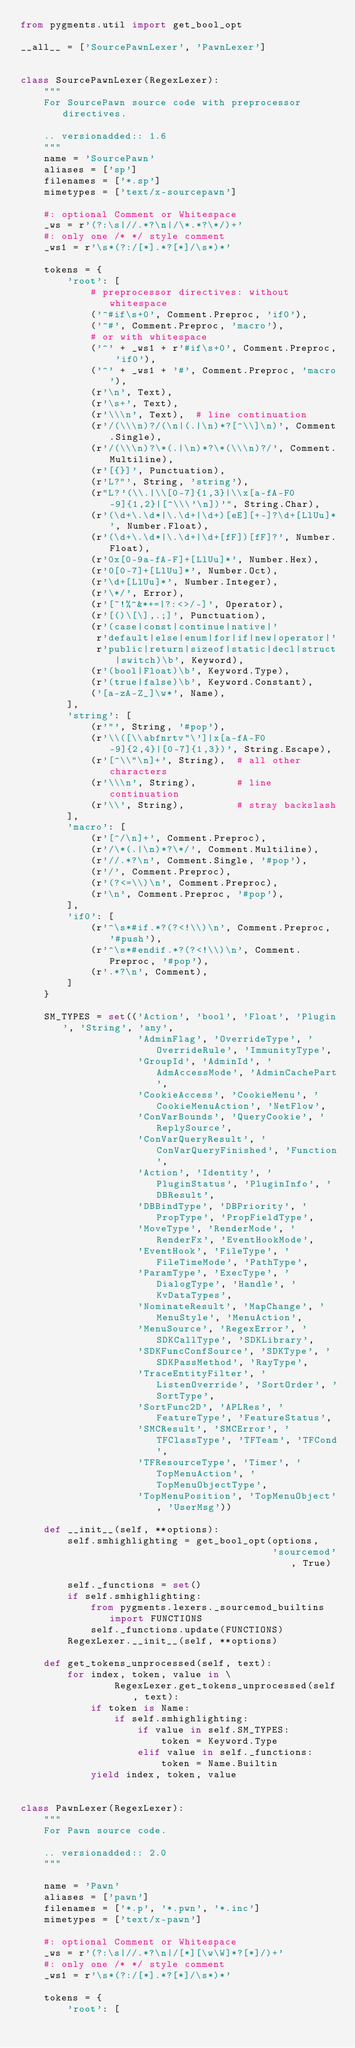Convert code to text. <code><loc_0><loc_0><loc_500><loc_500><_Python_>from pygments.util import get_bool_opt

__all__ = ['SourcePawnLexer', 'PawnLexer']


class SourcePawnLexer(RegexLexer):
    """
    For SourcePawn source code with preprocessor directives.

    .. versionadded:: 1.6
    """
    name = 'SourcePawn'
    aliases = ['sp']
    filenames = ['*.sp']
    mimetypes = ['text/x-sourcepawn']

    #: optional Comment or Whitespace
    _ws = r'(?:\s|//.*?\n|/\*.*?\*/)+'
    #: only one /* */ style comment
    _ws1 = r'\s*(?:/[*].*?[*]/\s*)*'

    tokens = {
        'root': [
            # preprocessor directives: without whitespace
            ('^#if\s+0', Comment.Preproc, 'if0'),
            ('^#', Comment.Preproc, 'macro'),
            # or with whitespace
            ('^' + _ws1 + r'#if\s+0', Comment.Preproc, 'if0'),
            ('^' + _ws1 + '#', Comment.Preproc, 'macro'),
            (r'\n', Text),
            (r'\s+', Text),
            (r'\\\n', Text),  # line continuation
            (r'/(\\\n)?/(\n|(.|\n)*?[^\\]\n)', Comment.Single),
            (r'/(\\\n)?\*(.|\n)*?\*(\\\n)?/', Comment.Multiline),
            (r'[{}]', Punctuation),
            (r'L?"', String, 'string'),
            (r"L?'(\\.|\\[0-7]{1,3}|\\x[a-fA-F0-9]{1,2}|[^\\\'\n])'", String.Char),
            (r'(\d+\.\d*|\.\d+|\d+)[eE][+-]?\d+[LlUu]*', Number.Float),
            (r'(\d+\.\d*|\.\d+|\d+[fF])[fF]?', Number.Float),
            (r'0x[0-9a-fA-F]+[LlUu]*', Number.Hex),
            (r'0[0-7]+[LlUu]*', Number.Oct),
            (r'\d+[LlUu]*', Number.Integer),
            (r'\*/', Error),
            (r'[~!%^&*+=|?:<>/-]', Operator),
            (r'[()\[\],.;]', Punctuation),
            (r'(case|const|continue|native|'
             r'default|else|enum|for|if|new|operator|'
             r'public|return|sizeof|static|decl|struct|switch)\b', Keyword),
            (r'(bool|Float)\b', Keyword.Type),
            (r'(true|false)\b', Keyword.Constant),
            ('[a-zA-Z_]\w*', Name),
        ],
        'string': [
            (r'"', String, '#pop'),
            (r'\\([\\abfnrtv"\']|x[a-fA-F0-9]{2,4}|[0-7]{1,3})', String.Escape),
            (r'[^\\"\n]+', String),  # all other characters
            (r'\\\n', String),       # line continuation
            (r'\\', String),         # stray backslash
        ],
        'macro': [
            (r'[^/\n]+', Comment.Preproc),
            (r'/\*(.|\n)*?\*/', Comment.Multiline),
            (r'//.*?\n', Comment.Single, '#pop'),
            (r'/', Comment.Preproc),
            (r'(?<=\\)\n', Comment.Preproc),
            (r'\n', Comment.Preproc, '#pop'),
        ],
        'if0': [
            (r'^\s*#if.*?(?<!\\)\n', Comment.Preproc, '#push'),
            (r'^\s*#endif.*?(?<!\\)\n', Comment.Preproc, '#pop'),
            (r'.*?\n', Comment),
        ]
    }

    SM_TYPES = set(('Action', 'bool', 'Float', 'Plugin', 'String', 'any',
                    'AdminFlag', 'OverrideType', 'OverrideRule', 'ImmunityType',
                    'GroupId', 'AdminId', 'AdmAccessMode', 'AdminCachePart',
                    'CookieAccess', 'CookieMenu', 'CookieMenuAction', 'NetFlow',
                    'ConVarBounds', 'QueryCookie', 'ReplySource',
                    'ConVarQueryResult', 'ConVarQueryFinished', 'Function',
                    'Action', 'Identity', 'PluginStatus', 'PluginInfo', 'DBResult',
                    'DBBindType', 'DBPriority', 'PropType', 'PropFieldType',
                    'MoveType', 'RenderMode', 'RenderFx', 'EventHookMode',
                    'EventHook', 'FileType', 'FileTimeMode', 'PathType',
                    'ParamType', 'ExecType', 'DialogType', 'Handle', 'KvDataTypes',
                    'NominateResult', 'MapChange', 'MenuStyle', 'MenuAction',
                    'MenuSource', 'RegexError', 'SDKCallType', 'SDKLibrary',
                    'SDKFuncConfSource', 'SDKType', 'SDKPassMethod', 'RayType',
                    'TraceEntityFilter', 'ListenOverride', 'SortOrder', 'SortType',
                    'SortFunc2D', 'APLRes', 'FeatureType', 'FeatureStatus',
                    'SMCResult', 'SMCError', 'TFClassType', 'TFTeam', 'TFCond',
                    'TFResourceType', 'Timer', 'TopMenuAction', 'TopMenuObjectType',
                    'TopMenuPosition', 'TopMenuObject', 'UserMsg'))

    def __init__(self, **options):
        self.smhighlighting = get_bool_opt(options,
                                           'sourcemod', True)

        self._functions = set()
        if self.smhighlighting:
            from pygments.lexers._sourcemod_builtins import FUNCTIONS
            self._functions.update(FUNCTIONS)
        RegexLexer.__init__(self, **options)

    def get_tokens_unprocessed(self, text):
        for index, token, value in \
                RegexLexer.get_tokens_unprocessed(self, text):
            if token is Name:
                if self.smhighlighting:
                    if value in self.SM_TYPES:
                        token = Keyword.Type
                    elif value in self._functions:
                        token = Name.Builtin
            yield index, token, value


class PawnLexer(RegexLexer):
    """
    For Pawn source code.

    .. versionadded:: 2.0
    """

    name = 'Pawn'
    aliases = ['pawn']
    filenames = ['*.p', '*.pwn', '*.inc']
    mimetypes = ['text/x-pawn']

    #: optional Comment or Whitespace
    _ws = r'(?:\s|//.*?\n|/[*][\w\W]*?[*]/)+'
    #: only one /* */ style comment
    _ws1 = r'\s*(?:/[*].*?[*]/\s*)*'

    tokens = {
        'root': [</code> 